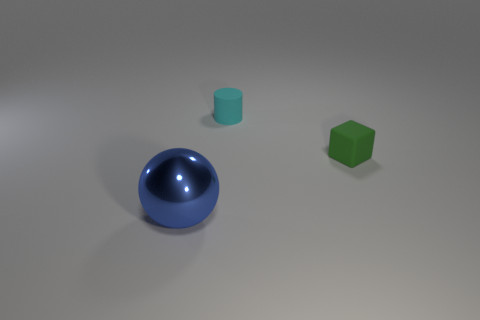Is there any other thing that is the same material as the large blue thing?
Make the answer very short. No. There is a tiny rubber thing on the right side of the rubber object behind the block; is there a cyan cylinder that is on the left side of it?
Offer a terse response. Yes. What is the tiny thing that is on the left side of the cube made of?
Give a very brief answer. Rubber. What number of tiny things are cyan metallic spheres or blue shiny balls?
Keep it short and to the point. 0. There is a matte thing in front of the cyan rubber cylinder; is its size the same as the ball?
Ensure brevity in your answer.  No. How many other things are the same color as the large shiny object?
Ensure brevity in your answer.  0. What is the material of the cyan cylinder?
Offer a terse response. Rubber. There is a object that is right of the blue thing and to the left of the green block; what material is it?
Provide a short and direct response. Rubber. How many things are things that are on the right side of the big blue ball or green rubber objects?
Your answer should be compact. 2. Is there a green matte block that has the same size as the cyan cylinder?
Your response must be concise. Yes. 